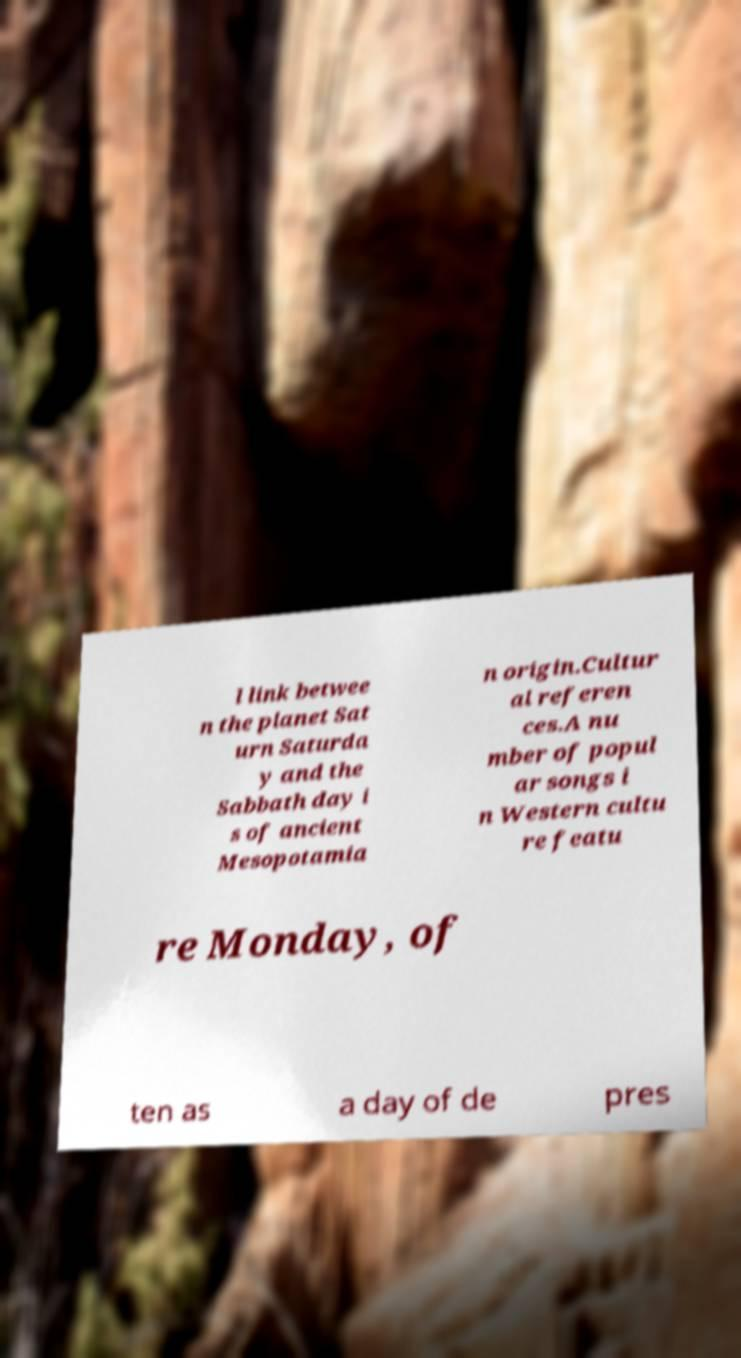There's text embedded in this image that I need extracted. Can you transcribe it verbatim? l link betwee n the planet Sat urn Saturda y and the Sabbath day i s of ancient Mesopotamia n origin.Cultur al referen ces.A nu mber of popul ar songs i n Western cultu re featu re Monday, of ten as a day of de pres 